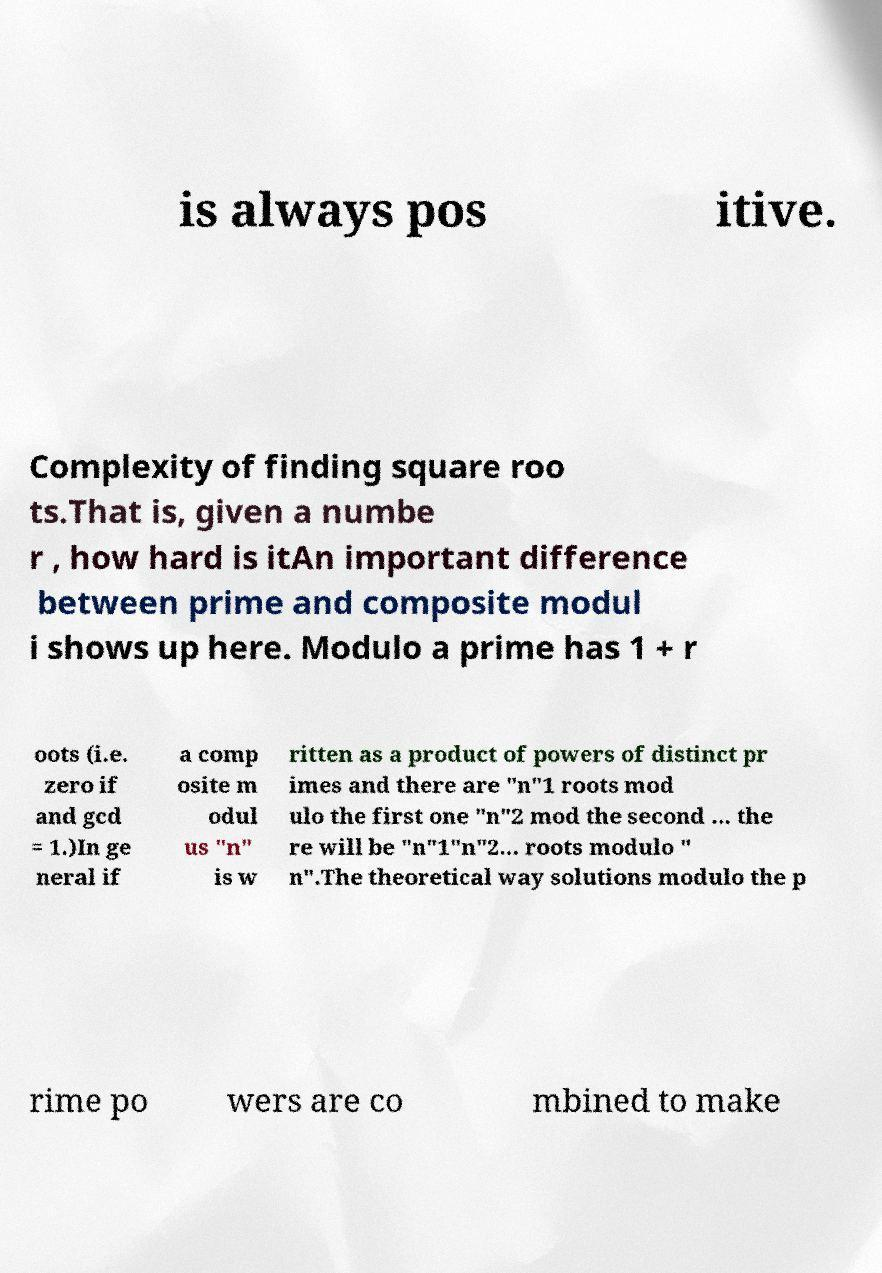Please identify and transcribe the text found in this image. is always pos itive. Complexity of finding square roo ts.That is, given a numbe r , how hard is itAn important difference between prime and composite modul i shows up here. Modulo a prime has 1 + r oots (i.e. zero if and gcd = 1.)In ge neral if a comp osite m odul us "n" is w ritten as a product of powers of distinct pr imes and there are "n"1 roots mod ulo the first one "n"2 mod the second ... the re will be "n"1"n"2... roots modulo " n".The theoretical way solutions modulo the p rime po wers are co mbined to make 